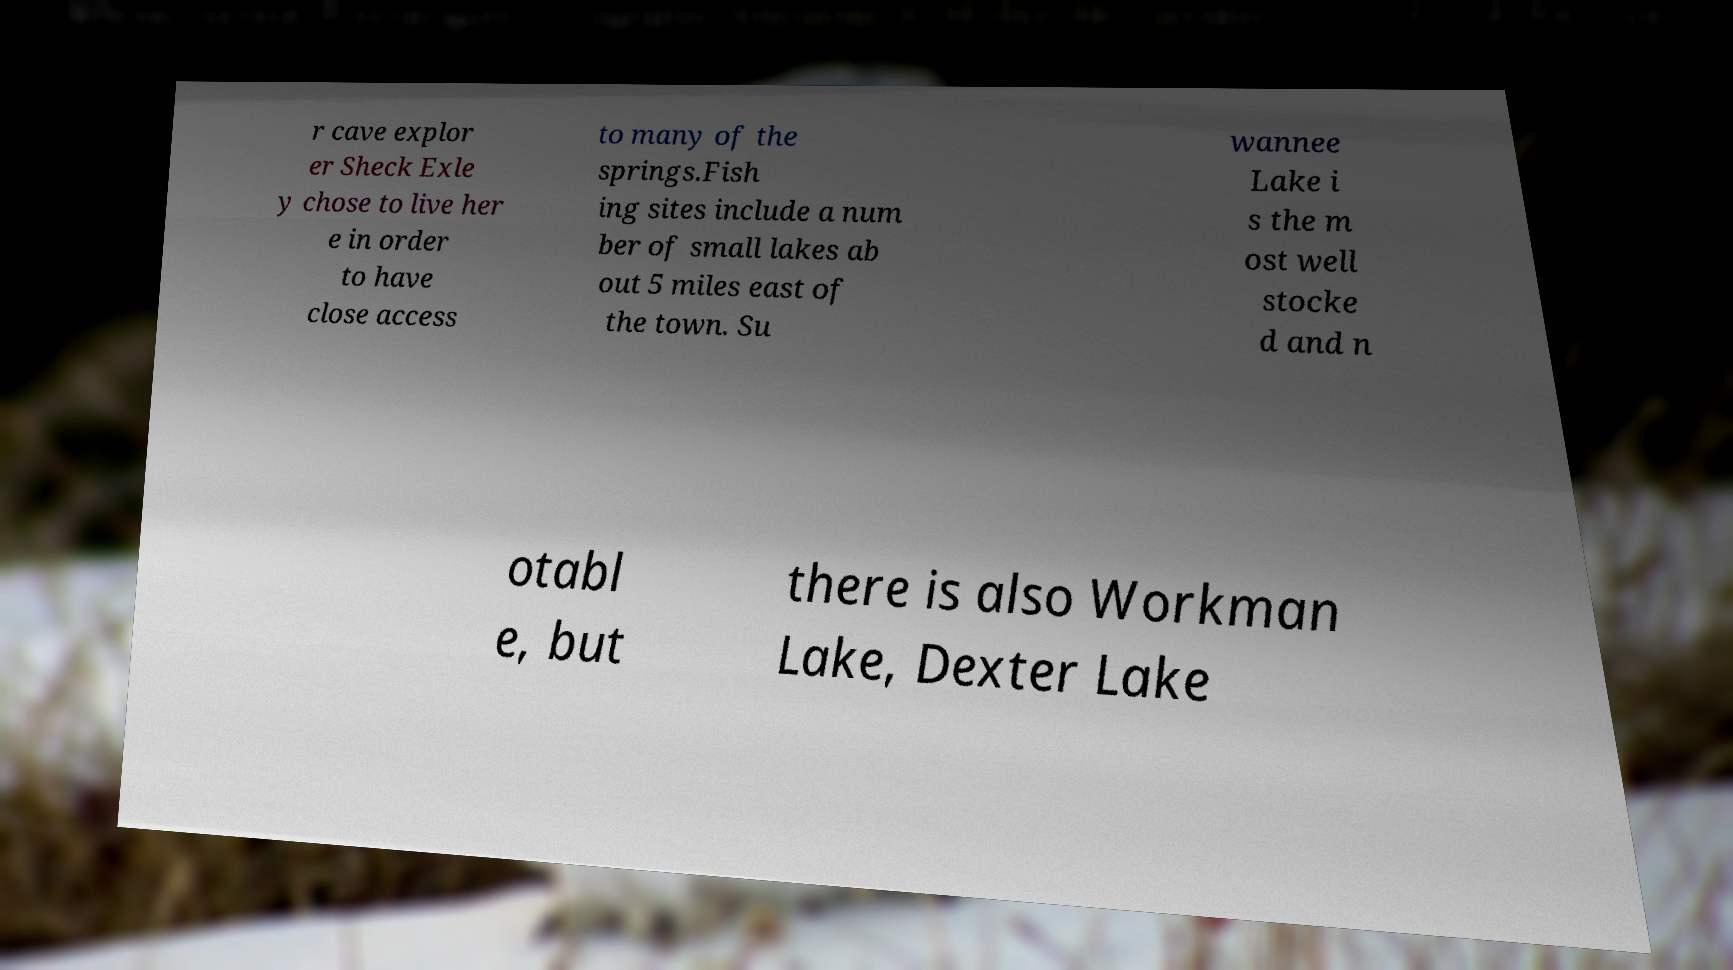Please read and relay the text visible in this image. What does it say? r cave explor er Sheck Exle y chose to live her e in order to have close access to many of the springs.Fish ing sites include a num ber of small lakes ab out 5 miles east of the town. Su wannee Lake i s the m ost well stocke d and n otabl e, but there is also Workman Lake, Dexter Lake 